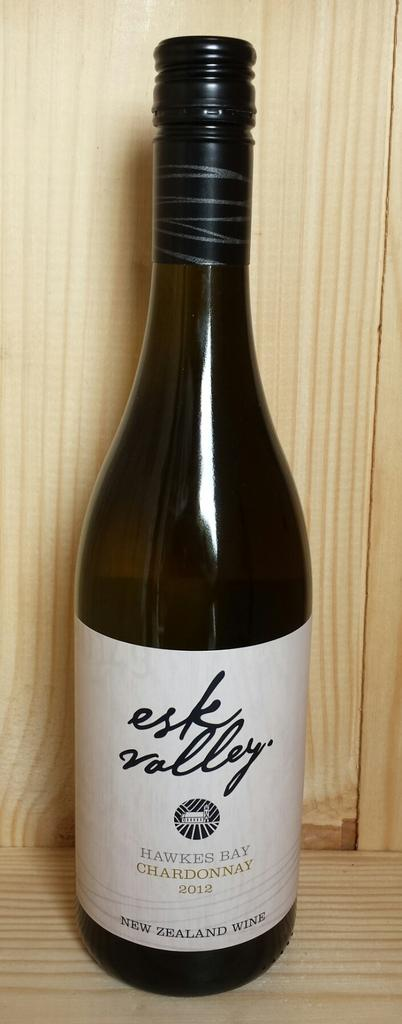<image>
Create a compact narrative representing the image presented. Esk Valley Hawkesbay Chardonnay 2012 wine from Newzealand in dark color bottle 